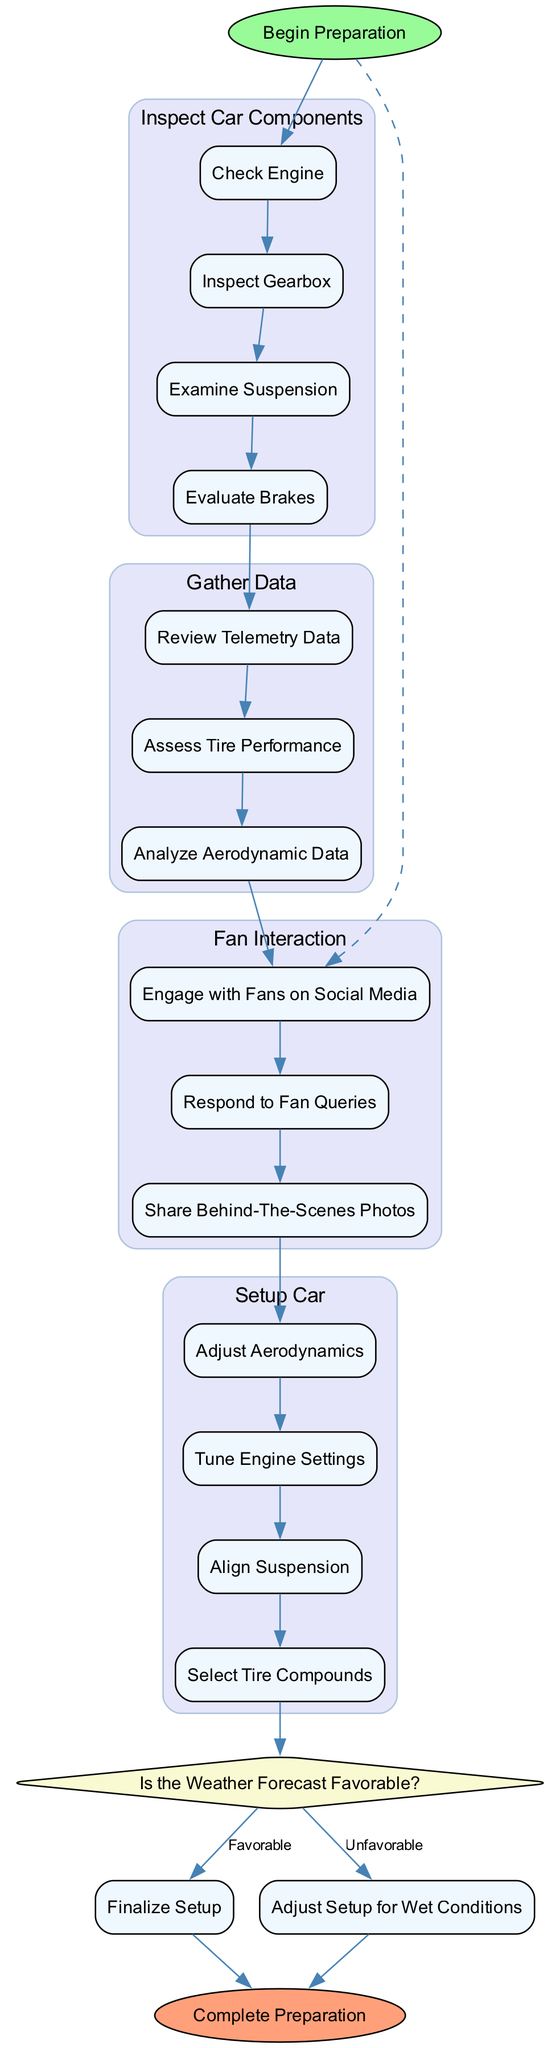What is the first activity in the diagram? The diagram begins with the node labeled "Begin Preparation," and the first activity follows, which is "Inspect Car Components."
Answer: Inspect Car Components How many actions are there under the "Setup Car" activity? The "Setup Car" activity has four actions listed: "Adjust Aerodynamics," "Tune Engine Settings," "Align Suspension," and "Select Tire Compounds." Therefore, there are four actions in that activity.
Answer: 4 What decision needs to be made before finalizing the setup? The decision made before finalizing the setup is based on the weather conditions, specifically whether the weather forecast is favorable or not.
Answer: Weather Conditions What happens if the weather is unfavorable? If the weather is unfavorable, the next activity is to "Adjust Setup for Wet Conditions" as indicated in the decision branches that follow the "Weather Conditions" question.
Answer: Adjust Setup for Wet Conditions How many activities are there in total in the diagram? The diagram consists of four main activities: "Inspect Car Components," "Gather Data," "Fan Interaction," and "Setup Car." Therefore, there are a total of four activities.
Answer: 4 Which activity involves engaging with fans? The activity that involves engaging with fans is labeled as "Fan Interaction," where actions include engaging with fans on social media, responding to fan queries, and sharing behind-the-scenes photos.
Answer: Fan Interaction Is there a dashed edge in the diagram? Yes, there is a dashed edge that connects "Begin Preparation" to "Engage with Fans on Social Media," which signifies a more indirect relationship.
Answer: Yes Which activity comes after "Gather Data"? After "Gather Data," the next activity in the flow is "Fan Interaction," indicating the sequence of activities in preparing the race car for the Grand Prix weekend.
Answer: Fan Interaction 